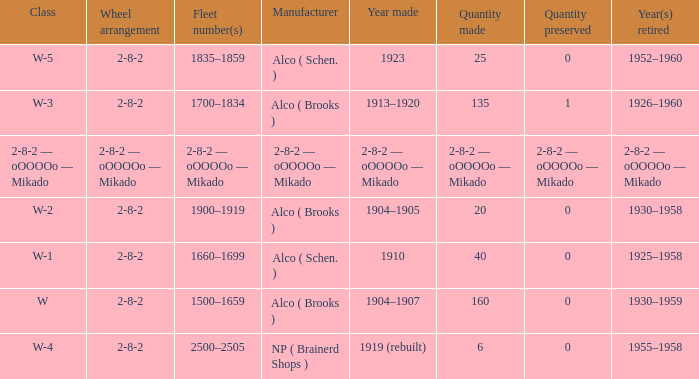What year did the retirement occur for the locomotive with a production quantity of 25? 1952–1960. 